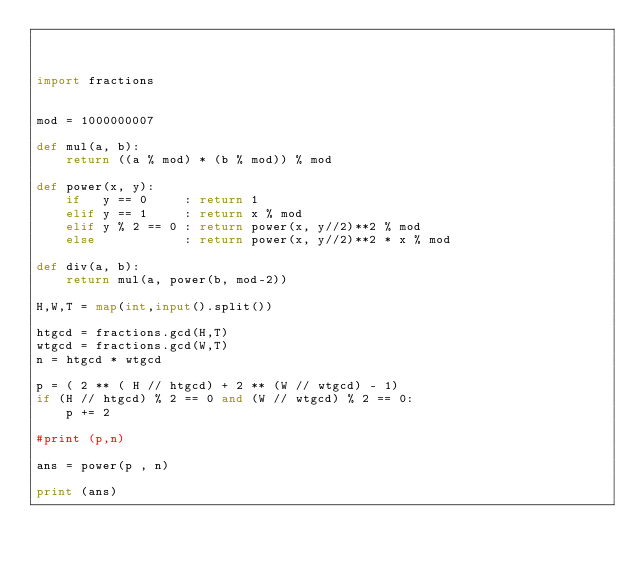<code> <loc_0><loc_0><loc_500><loc_500><_Python_>


import fractions


mod = 1000000007

def mul(a, b):
    return ((a % mod) * (b % mod)) % mod

def power(x, y):
    if   y == 0     : return 1
    elif y == 1     : return x % mod
    elif y % 2 == 0 : return power(x, y//2)**2 % mod
    else            : return power(x, y//2)**2 * x % mod

def div(a, b):
    return mul(a, power(b, mod-2))

H,W,T = map(int,input().split())

htgcd = fractions.gcd(H,T)
wtgcd = fractions.gcd(W,T)
n = htgcd * wtgcd

p = ( 2 ** ( H // htgcd) + 2 ** (W // wtgcd) - 1)
if (H // htgcd) % 2 == 0 and (W // wtgcd) % 2 == 0:
    p += 2

#print (p,n)

ans = power(p , n)

print (ans)

</code> 